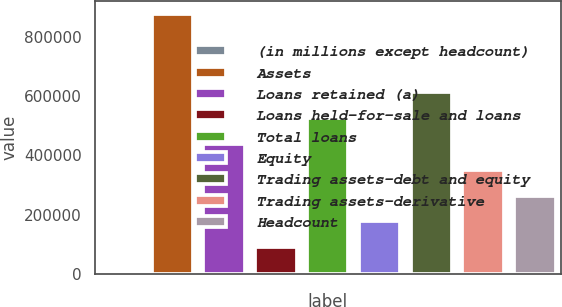<chart> <loc_0><loc_0><loc_500><loc_500><bar_chart><fcel>(in millions except headcount)<fcel>Assets<fcel>Loans retained (a)<fcel>Loans held-for-sale and loans<fcel>Total loans<fcel>Equity<fcel>Trading assets-debt and equity<fcel>Trading assets-derivative<fcel>Headcount<nl><fcel>2012<fcel>876107<fcel>439060<fcel>89421.5<fcel>526469<fcel>176831<fcel>613878<fcel>351650<fcel>264240<nl></chart> 